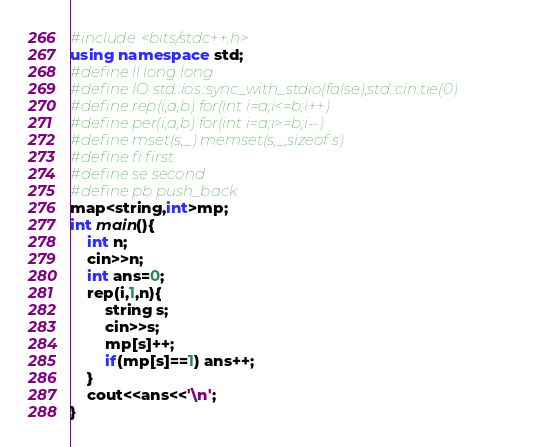<code> <loc_0><loc_0><loc_500><loc_500><_C++_>#include<bits/stdc++.h>
using namespace std;
#define ll long long
#define IO std::ios::sync_with_stdio(false);std::cin.tie(0)
#define rep(i,a,b) for(int i=a;i<=b;i++)
#define per(i,a,b) for(int i=a;i>=b;i--)
#define mset(s,_) memset(s,_,sizeof s)
#define fi first
#define se second
#define pb push_back
map<string,int>mp;
int main(){
	int n;
	cin>>n;
	int ans=0;
	rep(i,1,n){
		string s;
		cin>>s;
		mp[s]++;
		if(mp[s]==1) ans++;
	}
	cout<<ans<<'\n';
}</code> 